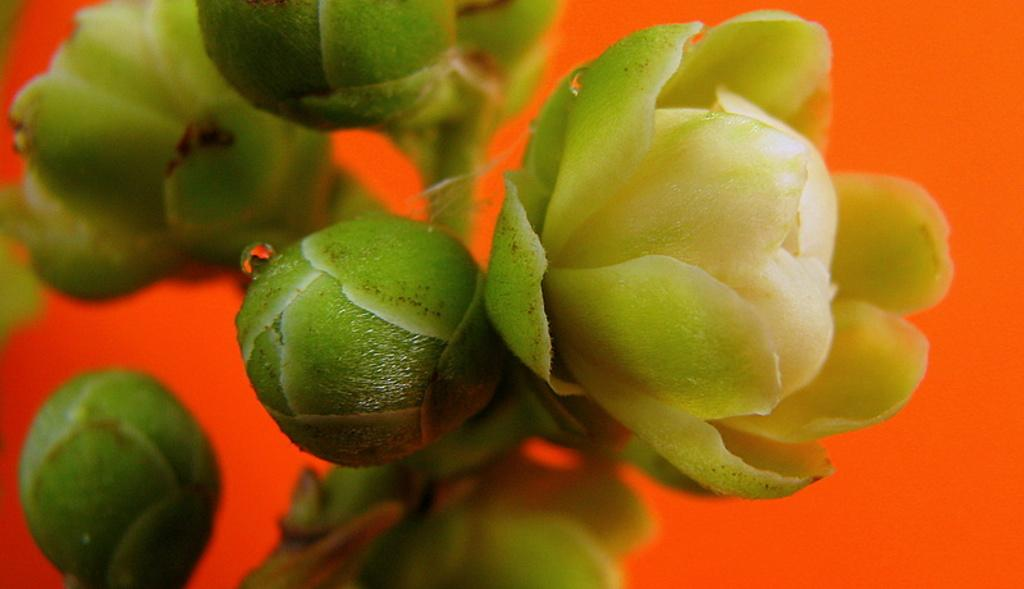What type of plants can be seen in the image? There are flowers in the image. What stage of growth are some of the flowers in? There are buds on a stem in the image. What color is the background of the image? The background of the image is orange. What type of jewel is embedded in the sand in the image? There is no sand or jewel present in the image; it features flowers and an orange background. 